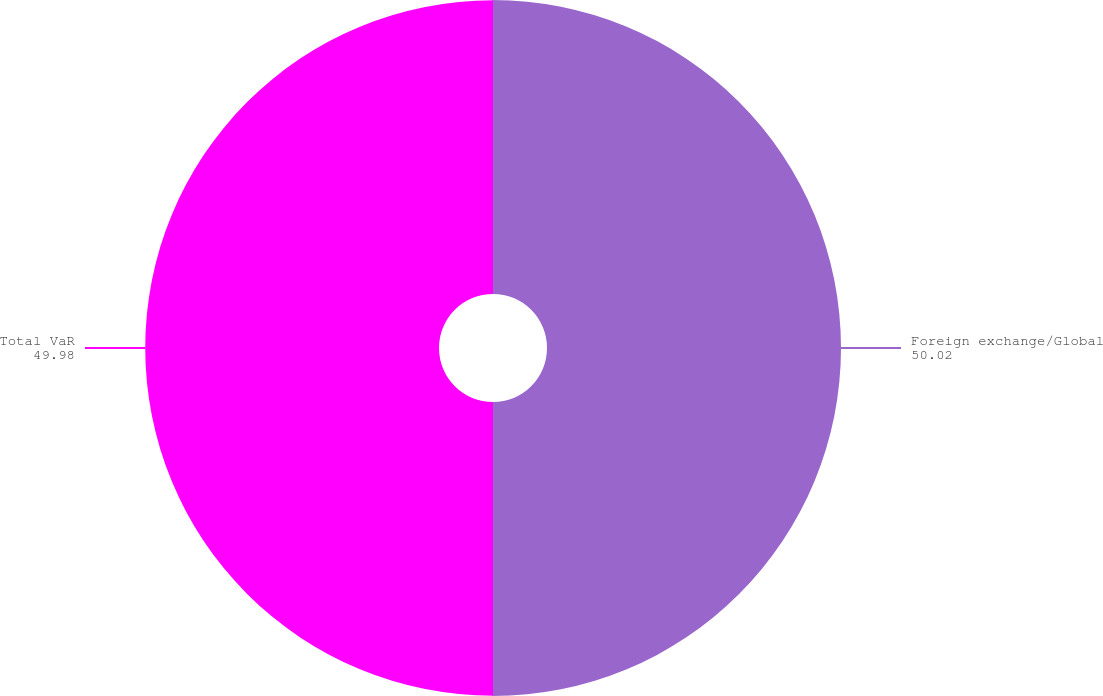Convert chart to OTSL. <chart><loc_0><loc_0><loc_500><loc_500><pie_chart><fcel>Foreign exchange/Global<fcel>Total VaR<nl><fcel>50.02%<fcel>49.98%<nl></chart> 